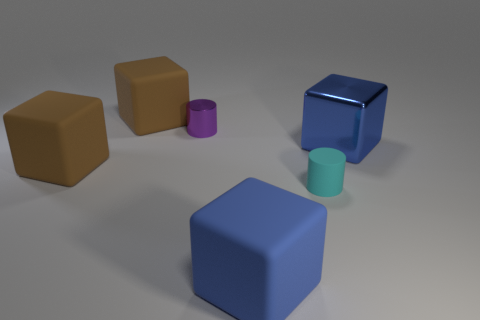Add 2 large brown matte blocks. How many objects exist? 8 Subtract all cylinders. How many objects are left? 4 Add 6 green metal blocks. How many green metal blocks exist? 6 Subtract 1 cyan cylinders. How many objects are left? 5 Subtract all shiny blocks. Subtract all cyan matte cylinders. How many objects are left? 4 Add 1 brown rubber cubes. How many brown rubber cubes are left? 3 